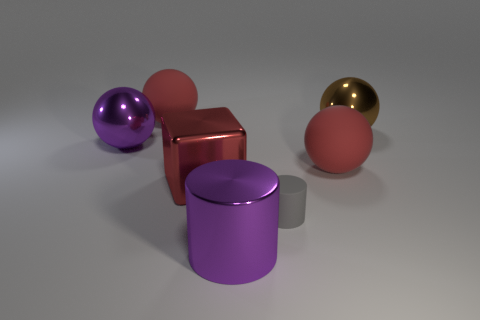Subtract all purple cylinders. How many cylinders are left? 1 Subtract all cubes. How many objects are left? 6 Subtract 1 cylinders. How many cylinders are left? 1 Subtract all shiny cylinders. Subtract all small blue cylinders. How many objects are left? 6 Add 1 purple cylinders. How many purple cylinders are left? 2 Add 3 tiny gray cylinders. How many tiny gray cylinders exist? 4 Add 1 large spheres. How many objects exist? 8 Subtract 2 red balls. How many objects are left? 5 Subtract all gray balls. Subtract all blue blocks. How many balls are left? 4 Subtract all cyan spheres. How many purple cylinders are left? 1 